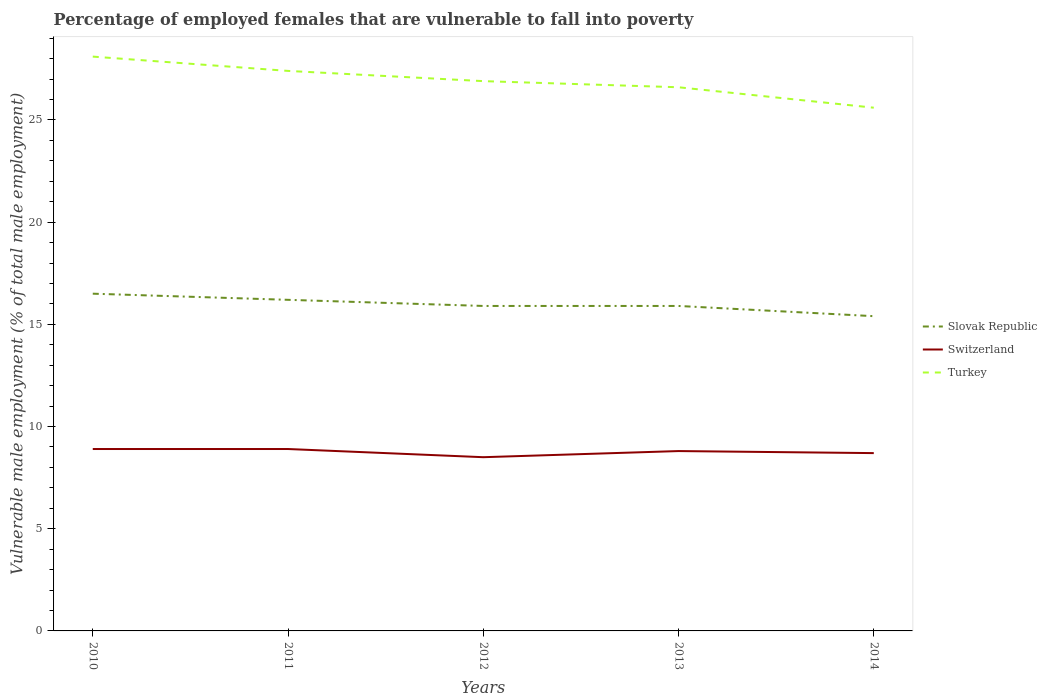Across all years, what is the maximum percentage of employed females who are vulnerable to fall into poverty in Slovak Republic?
Offer a terse response. 15.4. In which year was the percentage of employed females who are vulnerable to fall into poverty in Switzerland maximum?
Make the answer very short. 2012. What is the total percentage of employed females who are vulnerable to fall into poverty in Switzerland in the graph?
Give a very brief answer. 0.4. What is the difference between the highest and the second highest percentage of employed females who are vulnerable to fall into poverty in Turkey?
Make the answer very short. 2.5. Is the percentage of employed females who are vulnerable to fall into poverty in Switzerland strictly greater than the percentage of employed females who are vulnerable to fall into poverty in Slovak Republic over the years?
Your answer should be very brief. Yes. How many lines are there?
Provide a short and direct response. 3. How many years are there in the graph?
Provide a succinct answer. 5. What is the title of the graph?
Your response must be concise. Percentage of employed females that are vulnerable to fall into poverty. What is the label or title of the X-axis?
Your response must be concise. Years. What is the label or title of the Y-axis?
Your answer should be very brief. Vulnerable male employment (% of total male employment). What is the Vulnerable male employment (% of total male employment) in Slovak Republic in 2010?
Your response must be concise. 16.5. What is the Vulnerable male employment (% of total male employment) in Switzerland in 2010?
Your answer should be compact. 8.9. What is the Vulnerable male employment (% of total male employment) of Turkey in 2010?
Provide a succinct answer. 28.1. What is the Vulnerable male employment (% of total male employment) in Slovak Republic in 2011?
Offer a terse response. 16.2. What is the Vulnerable male employment (% of total male employment) in Switzerland in 2011?
Give a very brief answer. 8.9. What is the Vulnerable male employment (% of total male employment) of Turkey in 2011?
Offer a very short reply. 27.4. What is the Vulnerable male employment (% of total male employment) in Slovak Republic in 2012?
Provide a short and direct response. 15.9. What is the Vulnerable male employment (% of total male employment) in Turkey in 2012?
Provide a short and direct response. 26.9. What is the Vulnerable male employment (% of total male employment) of Slovak Republic in 2013?
Keep it short and to the point. 15.9. What is the Vulnerable male employment (% of total male employment) of Switzerland in 2013?
Offer a very short reply. 8.8. What is the Vulnerable male employment (% of total male employment) of Turkey in 2013?
Provide a succinct answer. 26.6. What is the Vulnerable male employment (% of total male employment) in Slovak Republic in 2014?
Provide a short and direct response. 15.4. What is the Vulnerable male employment (% of total male employment) in Switzerland in 2014?
Your answer should be compact. 8.7. What is the Vulnerable male employment (% of total male employment) of Turkey in 2014?
Provide a succinct answer. 25.6. Across all years, what is the maximum Vulnerable male employment (% of total male employment) in Slovak Republic?
Provide a succinct answer. 16.5. Across all years, what is the maximum Vulnerable male employment (% of total male employment) in Switzerland?
Keep it short and to the point. 8.9. Across all years, what is the maximum Vulnerable male employment (% of total male employment) of Turkey?
Your answer should be compact. 28.1. Across all years, what is the minimum Vulnerable male employment (% of total male employment) in Slovak Republic?
Provide a succinct answer. 15.4. Across all years, what is the minimum Vulnerable male employment (% of total male employment) of Switzerland?
Provide a short and direct response. 8.5. Across all years, what is the minimum Vulnerable male employment (% of total male employment) in Turkey?
Make the answer very short. 25.6. What is the total Vulnerable male employment (% of total male employment) in Slovak Republic in the graph?
Your answer should be compact. 79.9. What is the total Vulnerable male employment (% of total male employment) of Switzerland in the graph?
Provide a succinct answer. 43.8. What is the total Vulnerable male employment (% of total male employment) in Turkey in the graph?
Make the answer very short. 134.6. What is the difference between the Vulnerable male employment (% of total male employment) of Switzerland in 2010 and that in 2012?
Your response must be concise. 0.4. What is the difference between the Vulnerable male employment (% of total male employment) in Turkey in 2010 and that in 2012?
Your answer should be very brief. 1.2. What is the difference between the Vulnerable male employment (% of total male employment) of Switzerland in 2010 and that in 2013?
Ensure brevity in your answer.  0.1. What is the difference between the Vulnerable male employment (% of total male employment) in Slovak Republic in 2011 and that in 2012?
Your response must be concise. 0.3. What is the difference between the Vulnerable male employment (% of total male employment) in Turkey in 2011 and that in 2012?
Ensure brevity in your answer.  0.5. What is the difference between the Vulnerable male employment (% of total male employment) in Slovak Republic in 2011 and that in 2014?
Keep it short and to the point. 0.8. What is the difference between the Vulnerable male employment (% of total male employment) of Turkey in 2011 and that in 2014?
Provide a short and direct response. 1.8. What is the difference between the Vulnerable male employment (% of total male employment) of Turkey in 2012 and that in 2013?
Your answer should be very brief. 0.3. What is the difference between the Vulnerable male employment (% of total male employment) of Slovak Republic in 2012 and that in 2014?
Keep it short and to the point. 0.5. What is the difference between the Vulnerable male employment (% of total male employment) of Turkey in 2012 and that in 2014?
Keep it short and to the point. 1.3. What is the difference between the Vulnerable male employment (% of total male employment) of Slovak Republic in 2013 and that in 2014?
Your answer should be very brief. 0.5. What is the difference between the Vulnerable male employment (% of total male employment) in Turkey in 2013 and that in 2014?
Your response must be concise. 1. What is the difference between the Vulnerable male employment (% of total male employment) of Switzerland in 2010 and the Vulnerable male employment (% of total male employment) of Turkey in 2011?
Keep it short and to the point. -18.5. What is the difference between the Vulnerable male employment (% of total male employment) of Switzerland in 2010 and the Vulnerable male employment (% of total male employment) of Turkey in 2012?
Provide a succinct answer. -18. What is the difference between the Vulnerable male employment (% of total male employment) in Slovak Republic in 2010 and the Vulnerable male employment (% of total male employment) in Switzerland in 2013?
Give a very brief answer. 7.7. What is the difference between the Vulnerable male employment (% of total male employment) in Slovak Republic in 2010 and the Vulnerable male employment (% of total male employment) in Turkey in 2013?
Offer a very short reply. -10.1. What is the difference between the Vulnerable male employment (% of total male employment) in Switzerland in 2010 and the Vulnerable male employment (% of total male employment) in Turkey in 2013?
Provide a succinct answer. -17.7. What is the difference between the Vulnerable male employment (% of total male employment) of Slovak Republic in 2010 and the Vulnerable male employment (% of total male employment) of Switzerland in 2014?
Offer a very short reply. 7.8. What is the difference between the Vulnerable male employment (% of total male employment) in Switzerland in 2010 and the Vulnerable male employment (% of total male employment) in Turkey in 2014?
Your answer should be very brief. -16.7. What is the difference between the Vulnerable male employment (% of total male employment) in Switzerland in 2011 and the Vulnerable male employment (% of total male employment) in Turkey in 2012?
Your answer should be very brief. -18. What is the difference between the Vulnerable male employment (% of total male employment) of Slovak Republic in 2011 and the Vulnerable male employment (% of total male employment) of Switzerland in 2013?
Keep it short and to the point. 7.4. What is the difference between the Vulnerable male employment (% of total male employment) in Switzerland in 2011 and the Vulnerable male employment (% of total male employment) in Turkey in 2013?
Offer a very short reply. -17.7. What is the difference between the Vulnerable male employment (% of total male employment) of Switzerland in 2011 and the Vulnerable male employment (% of total male employment) of Turkey in 2014?
Provide a short and direct response. -16.7. What is the difference between the Vulnerable male employment (% of total male employment) of Switzerland in 2012 and the Vulnerable male employment (% of total male employment) of Turkey in 2013?
Ensure brevity in your answer.  -18.1. What is the difference between the Vulnerable male employment (% of total male employment) in Switzerland in 2012 and the Vulnerable male employment (% of total male employment) in Turkey in 2014?
Your answer should be compact. -17.1. What is the difference between the Vulnerable male employment (% of total male employment) in Slovak Republic in 2013 and the Vulnerable male employment (% of total male employment) in Switzerland in 2014?
Keep it short and to the point. 7.2. What is the difference between the Vulnerable male employment (% of total male employment) of Slovak Republic in 2013 and the Vulnerable male employment (% of total male employment) of Turkey in 2014?
Your response must be concise. -9.7. What is the difference between the Vulnerable male employment (% of total male employment) of Switzerland in 2013 and the Vulnerable male employment (% of total male employment) of Turkey in 2014?
Your answer should be compact. -16.8. What is the average Vulnerable male employment (% of total male employment) of Slovak Republic per year?
Your response must be concise. 15.98. What is the average Vulnerable male employment (% of total male employment) of Switzerland per year?
Your answer should be very brief. 8.76. What is the average Vulnerable male employment (% of total male employment) of Turkey per year?
Provide a succinct answer. 26.92. In the year 2010, what is the difference between the Vulnerable male employment (% of total male employment) in Switzerland and Vulnerable male employment (% of total male employment) in Turkey?
Your answer should be compact. -19.2. In the year 2011, what is the difference between the Vulnerable male employment (% of total male employment) of Slovak Republic and Vulnerable male employment (% of total male employment) of Switzerland?
Offer a very short reply. 7.3. In the year 2011, what is the difference between the Vulnerable male employment (% of total male employment) of Switzerland and Vulnerable male employment (% of total male employment) of Turkey?
Your response must be concise. -18.5. In the year 2012, what is the difference between the Vulnerable male employment (% of total male employment) of Slovak Republic and Vulnerable male employment (% of total male employment) of Switzerland?
Offer a very short reply. 7.4. In the year 2012, what is the difference between the Vulnerable male employment (% of total male employment) of Slovak Republic and Vulnerable male employment (% of total male employment) of Turkey?
Offer a very short reply. -11. In the year 2012, what is the difference between the Vulnerable male employment (% of total male employment) in Switzerland and Vulnerable male employment (% of total male employment) in Turkey?
Your response must be concise. -18.4. In the year 2013, what is the difference between the Vulnerable male employment (% of total male employment) of Slovak Republic and Vulnerable male employment (% of total male employment) of Switzerland?
Keep it short and to the point. 7.1. In the year 2013, what is the difference between the Vulnerable male employment (% of total male employment) of Slovak Republic and Vulnerable male employment (% of total male employment) of Turkey?
Keep it short and to the point. -10.7. In the year 2013, what is the difference between the Vulnerable male employment (% of total male employment) of Switzerland and Vulnerable male employment (% of total male employment) of Turkey?
Make the answer very short. -17.8. In the year 2014, what is the difference between the Vulnerable male employment (% of total male employment) of Slovak Republic and Vulnerable male employment (% of total male employment) of Switzerland?
Provide a short and direct response. 6.7. In the year 2014, what is the difference between the Vulnerable male employment (% of total male employment) in Switzerland and Vulnerable male employment (% of total male employment) in Turkey?
Provide a short and direct response. -16.9. What is the ratio of the Vulnerable male employment (% of total male employment) in Slovak Republic in 2010 to that in 2011?
Provide a succinct answer. 1.02. What is the ratio of the Vulnerable male employment (% of total male employment) of Switzerland in 2010 to that in 2011?
Offer a very short reply. 1. What is the ratio of the Vulnerable male employment (% of total male employment) of Turkey in 2010 to that in 2011?
Make the answer very short. 1.03. What is the ratio of the Vulnerable male employment (% of total male employment) of Slovak Republic in 2010 to that in 2012?
Make the answer very short. 1.04. What is the ratio of the Vulnerable male employment (% of total male employment) in Switzerland in 2010 to that in 2012?
Offer a very short reply. 1.05. What is the ratio of the Vulnerable male employment (% of total male employment) of Turkey in 2010 to that in 2012?
Provide a succinct answer. 1.04. What is the ratio of the Vulnerable male employment (% of total male employment) in Slovak Republic in 2010 to that in 2013?
Offer a very short reply. 1.04. What is the ratio of the Vulnerable male employment (% of total male employment) of Switzerland in 2010 to that in 2013?
Ensure brevity in your answer.  1.01. What is the ratio of the Vulnerable male employment (% of total male employment) in Turkey in 2010 to that in 2013?
Offer a terse response. 1.06. What is the ratio of the Vulnerable male employment (% of total male employment) in Slovak Republic in 2010 to that in 2014?
Offer a very short reply. 1.07. What is the ratio of the Vulnerable male employment (% of total male employment) of Switzerland in 2010 to that in 2014?
Give a very brief answer. 1.02. What is the ratio of the Vulnerable male employment (% of total male employment) of Turkey in 2010 to that in 2014?
Ensure brevity in your answer.  1.1. What is the ratio of the Vulnerable male employment (% of total male employment) of Slovak Republic in 2011 to that in 2012?
Ensure brevity in your answer.  1.02. What is the ratio of the Vulnerable male employment (% of total male employment) of Switzerland in 2011 to that in 2012?
Your answer should be very brief. 1.05. What is the ratio of the Vulnerable male employment (% of total male employment) in Turkey in 2011 to that in 2012?
Ensure brevity in your answer.  1.02. What is the ratio of the Vulnerable male employment (% of total male employment) in Slovak Republic in 2011 to that in 2013?
Your answer should be very brief. 1.02. What is the ratio of the Vulnerable male employment (% of total male employment) of Switzerland in 2011 to that in 2013?
Offer a terse response. 1.01. What is the ratio of the Vulnerable male employment (% of total male employment) of Turkey in 2011 to that in 2013?
Provide a succinct answer. 1.03. What is the ratio of the Vulnerable male employment (% of total male employment) of Slovak Republic in 2011 to that in 2014?
Ensure brevity in your answer.  1.05. What is the ratio of the Vulnerable male employment (% of total male employment) in Turkey in 2011 to that in 2014?
Your response must be concise. 1.07. What is the ratio of the Vulnerable male employment (% of total male employment) in Switzerland in 2012 to that in 2013?
Your answer should be compact. 0.97. What is the ratio of the Vulnerable male employment (% of total male employment) in Turkey in 2012 to that in 2013?
Your answer should be very brief. 1.01. What is the ratio of the Vulnerable male employment (% of total male employment) of Slovak Republic in 2012 to that in 2014?
Your answer should be very brief. 1.03. What is the ratio of the Vulnerable male employment (% of total male employment) of Switzerland in 2012 to that in 2014?
Make the answer very short. 0.98. What is the ratio of the Vulnerable male employment (% of total male employment) in Turkey in 2012 to that in 2014?
Give a very brief answer. 1.05. What is the ratio of the Vulnerable male employment (% of total male employment) in Slovak Republic in 2013 to that in 2014?
Your response must be concise. 1.03. What is the ratio of the Vulnerable male employment (% of total male employment) in Switzerland in 2013 to that in 2014?
Your response must be concise. 1.01. What is the ratio of the Vulnerable male employment (% of total male employment) of Turkey in 2013 to that in 2014?
Make the answer very short. 1.04. What is the difference between the highest and the second highest Vulnerable male employment (% of total male employment) of Switzerland?
Ensure brevity in your answer.  0. What is the difference between the highest and the lowest Vulnerable male employment (% of total male employment) in Slovak Republic?
Your answer should be very brief. 1.1. What is the difference between the highest and the lowest Vulnerable male employment (% of total male employment) of Switzerland?
Provide a short and direct response. 0.4. What is the difference between the highest and the lowest Vulnerable male employment (% of total male employment) of Turkey?
Ensure brevity in your answer.  2.5. 